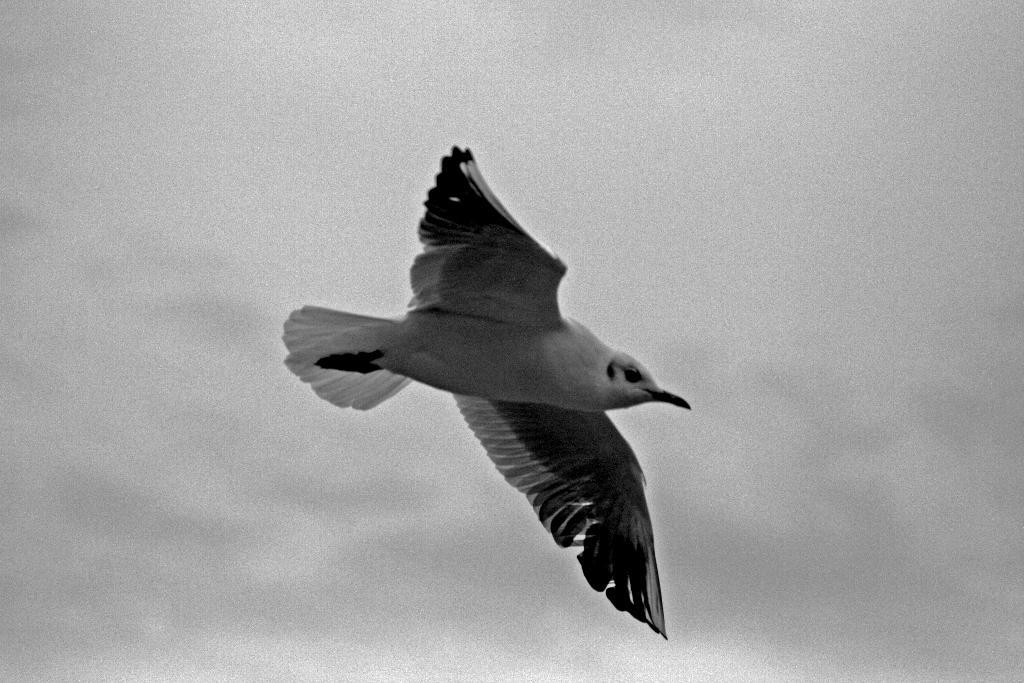What type of animal can be seen in the image? There is a bird in the image. What is the bird doing in the image? The bird is flying in the sky. What type of clouds can be seen surrounding the bird in the image? There is no mention of clouds in the provided facts, so we cannot determine if clouds are present in the image. What type of maid is visible in the image? There is no mention of a maid in the provided facts, so we cannot determine if a maid is present in the image. 